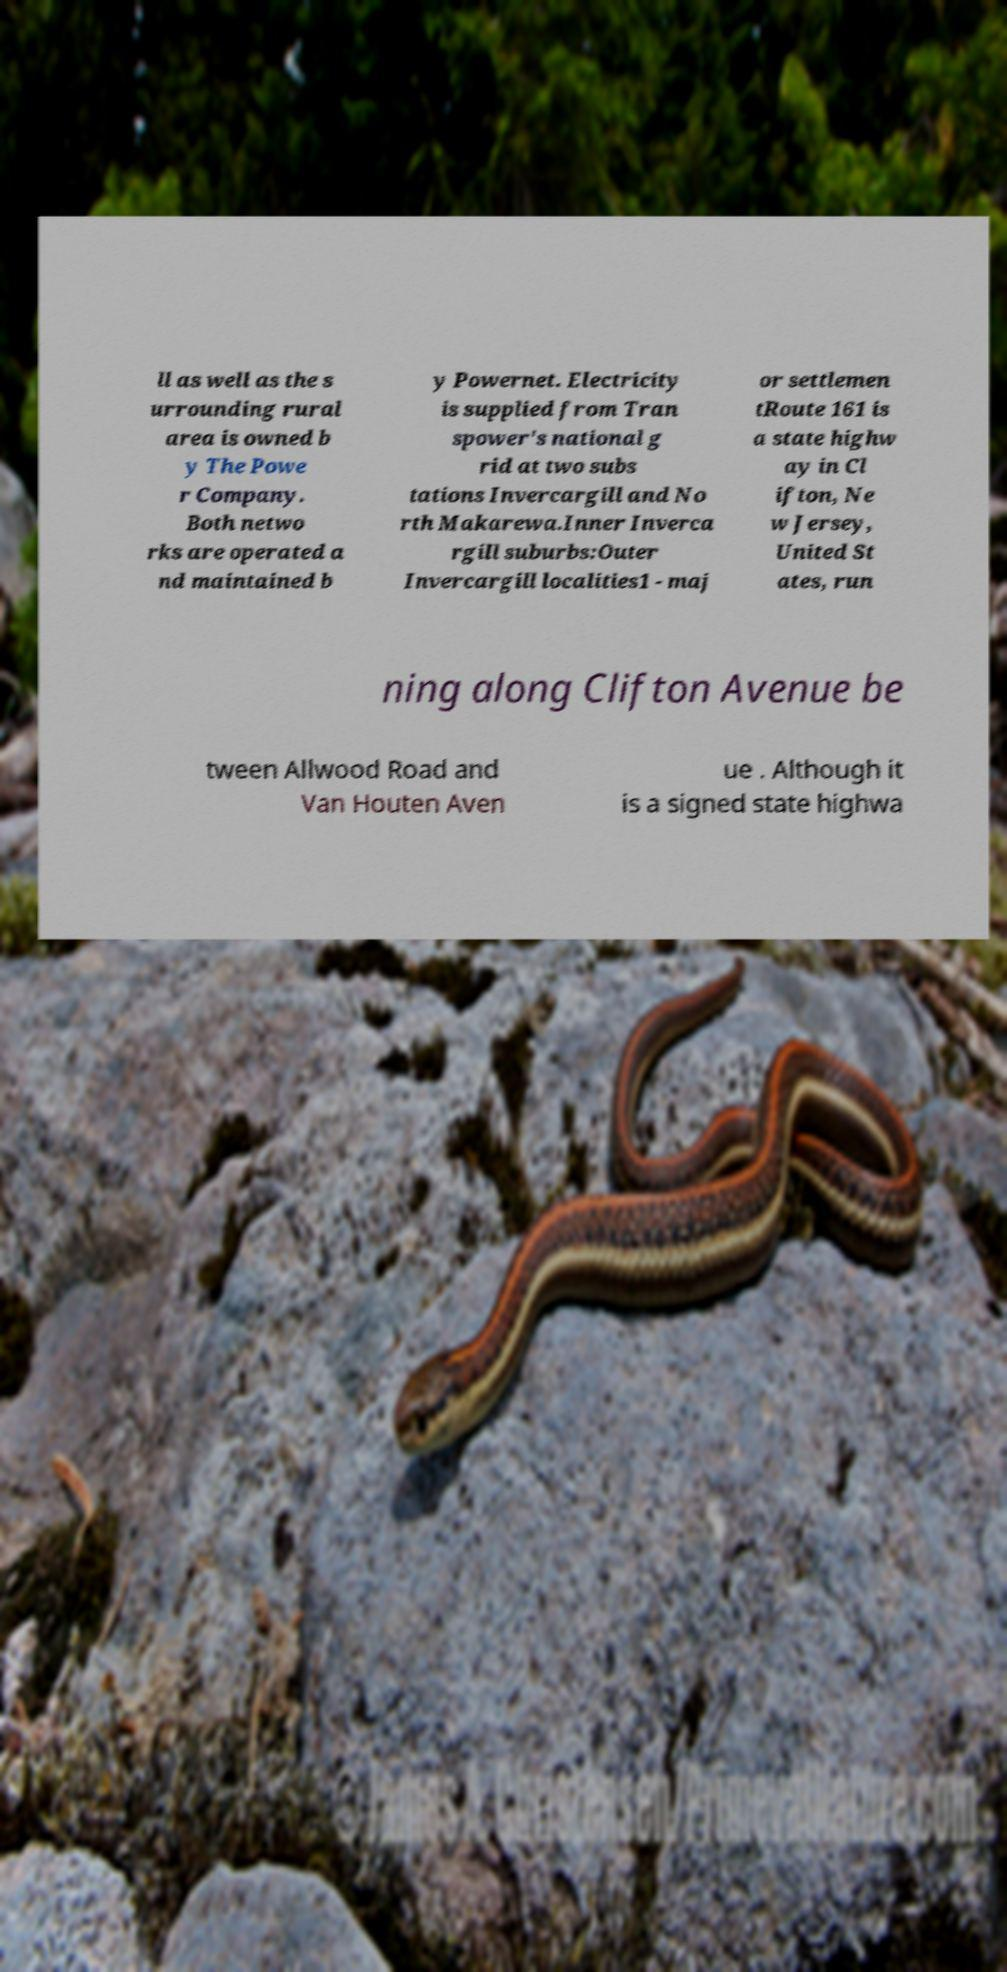What messages or text are displayed in this image? I need them in a readable, typed format. ll as well as the s urrounding rural area is owned b y The Powe r Company. Both netwo rks are operated a nd maintained b y Powernet. Electricity is supplied from Tran spower's national g rid at two subs tations Invercargill and No rth Makarewa.Inner Inverca rgill suburbs:Outer Invercargill localities1 - maj or settlemen tRoute 161 is a state highw ay in Cl ifton, Ne w Jersey, United St ates, run ning along Clifton Avenue be tween Allwood Road and Van Houten Aven ue . Although it is a signed state highwa 